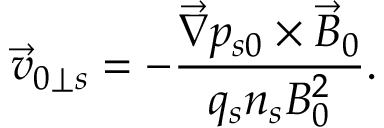Convert formula to latex. <formula><loc_0><loc_0><loc_500><loc_500>\vec { v } _ { 0 \perp s } = - \frac { \vec { \nabla } p _ { s 0 } \times \vec { B } _ { 0 } } { q _ { s } n _ { s } B _ { 0 } ^ { 2 } } .</formula> 